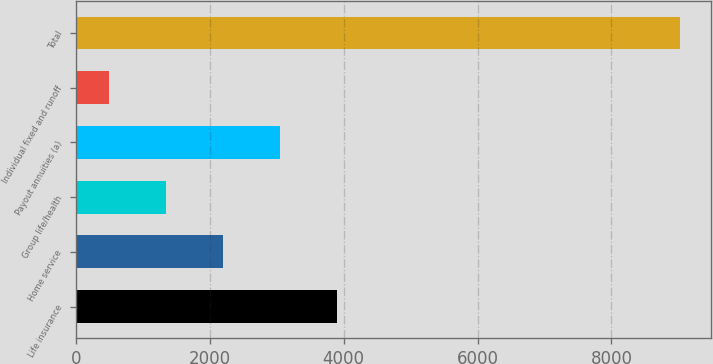Convert chart to OTSL. <chart><loc_0><loc_0><loc_500><loc_500><bar_chart><fcel>Life insurance<fcel>Home service<fcel>Group life/health<fcel>Payout annuities (a)<fcel>Individual fixed and runoff<fcel>Total<nl><fcel>3907<fcel>2200<fcel>1346.5<fcel>3053.5<fcel>493<fcel>9028<nl></chart> 